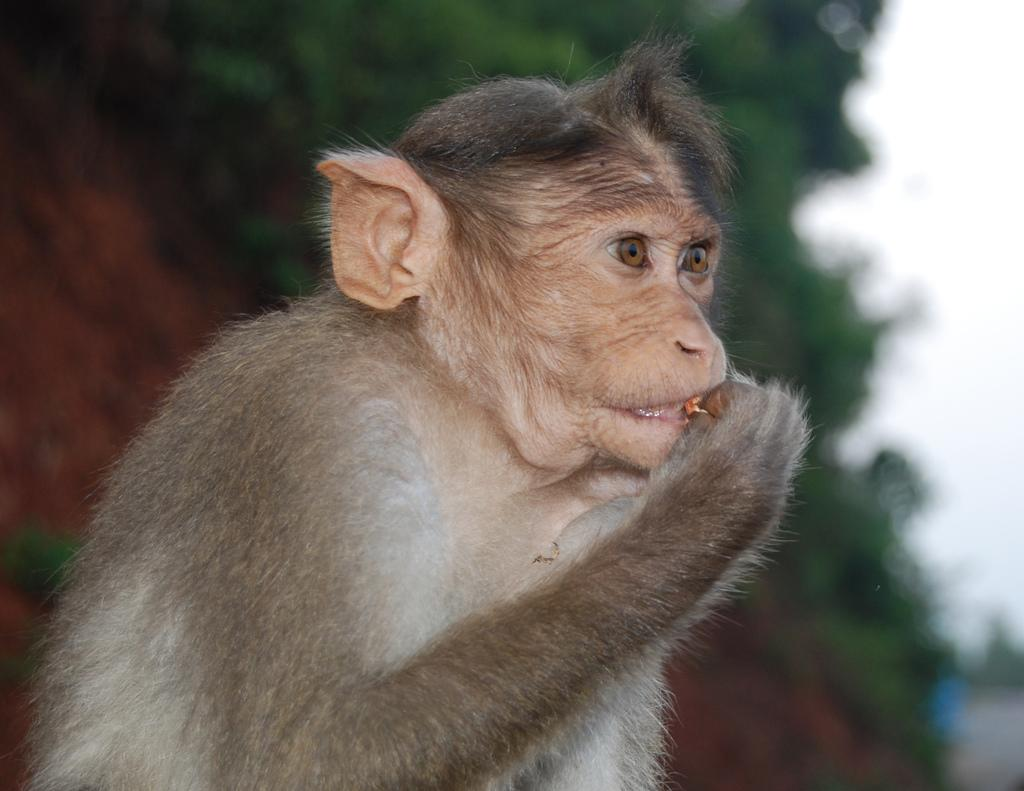What animal is present in the image? There is a monkey in the image. What is the monkey doing in the image? The monkey is eating something. Can you describe the background of the image? The background of the image is blurred. What type of map can be seen in the image? There is no map present in the image; it features a monkey eating something. What wish does the monkey have while eating in the image? There is no indication of the monkey's wishes in the image, as it only shows the monkey eating. 